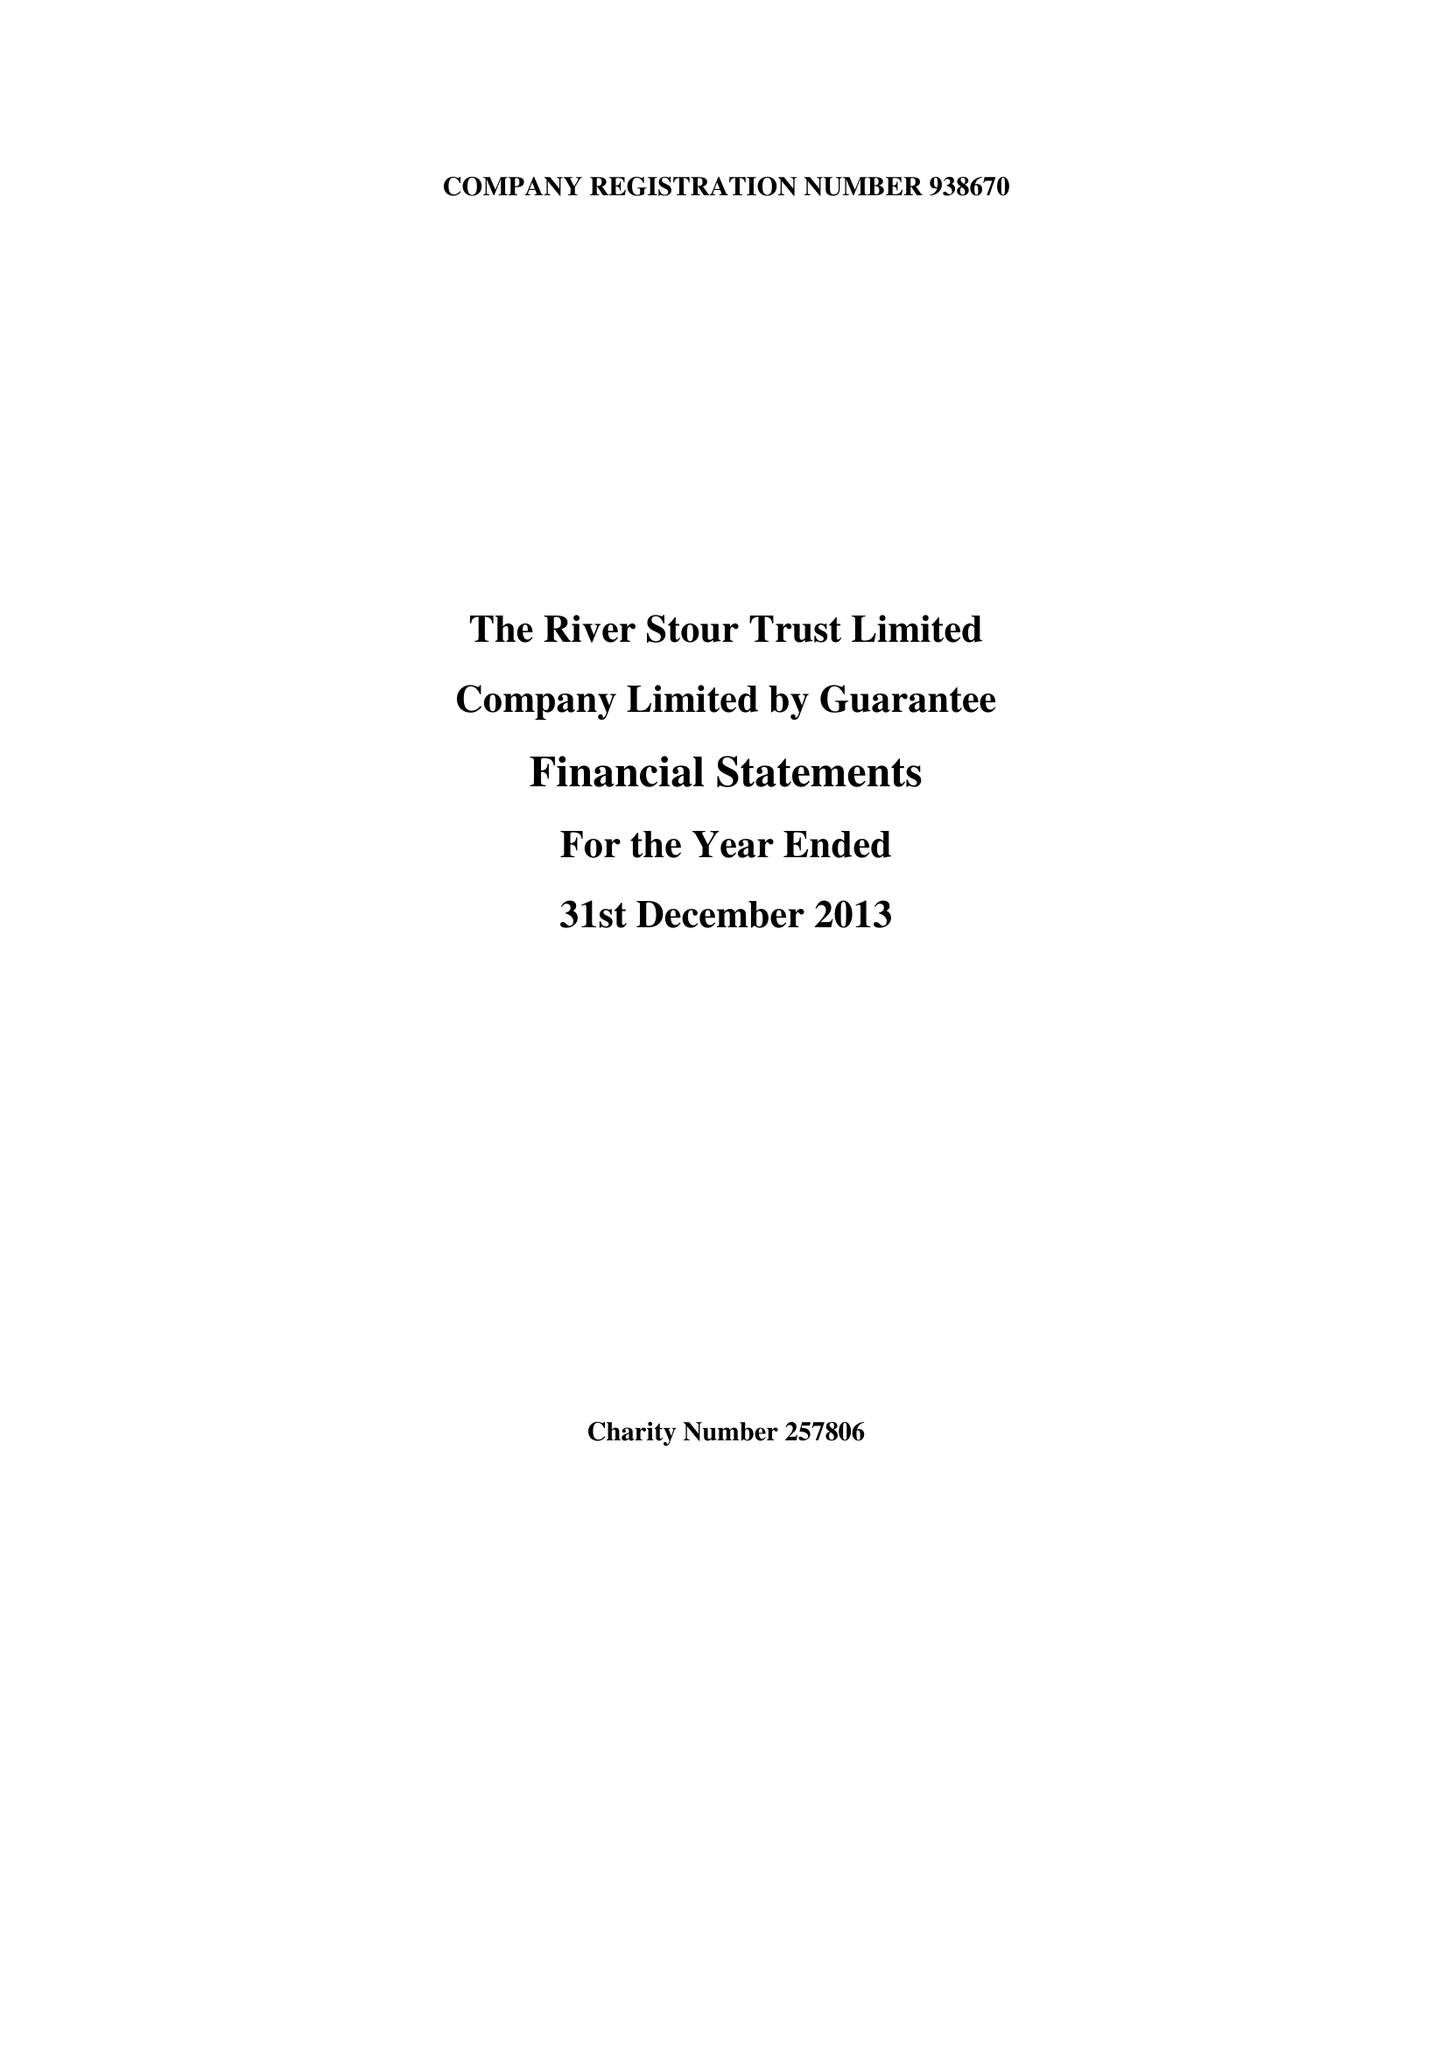What is the value for the income_annually_in_british_pounds?
Answer the question using a single word or phrase. 75286.00 